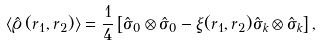Convert formula to latex. <formula><loc_0><loc_0><loc_500><loc_500>\langle \hat { \varrho } \, ( r _ { 1 } , r _ { 2 } ) \rangle = \frac { 1 } { 4 } \left [ \hat { \sigma } _ { 0 } \otimes \hat { \sigma } _ { 0 } - \xi ( r _ { 1 } , r _ { 2 } ) \hat { \sigma } _ { k } \otimes \hat { \sigma } _ { k } \right ] ,</formula> 